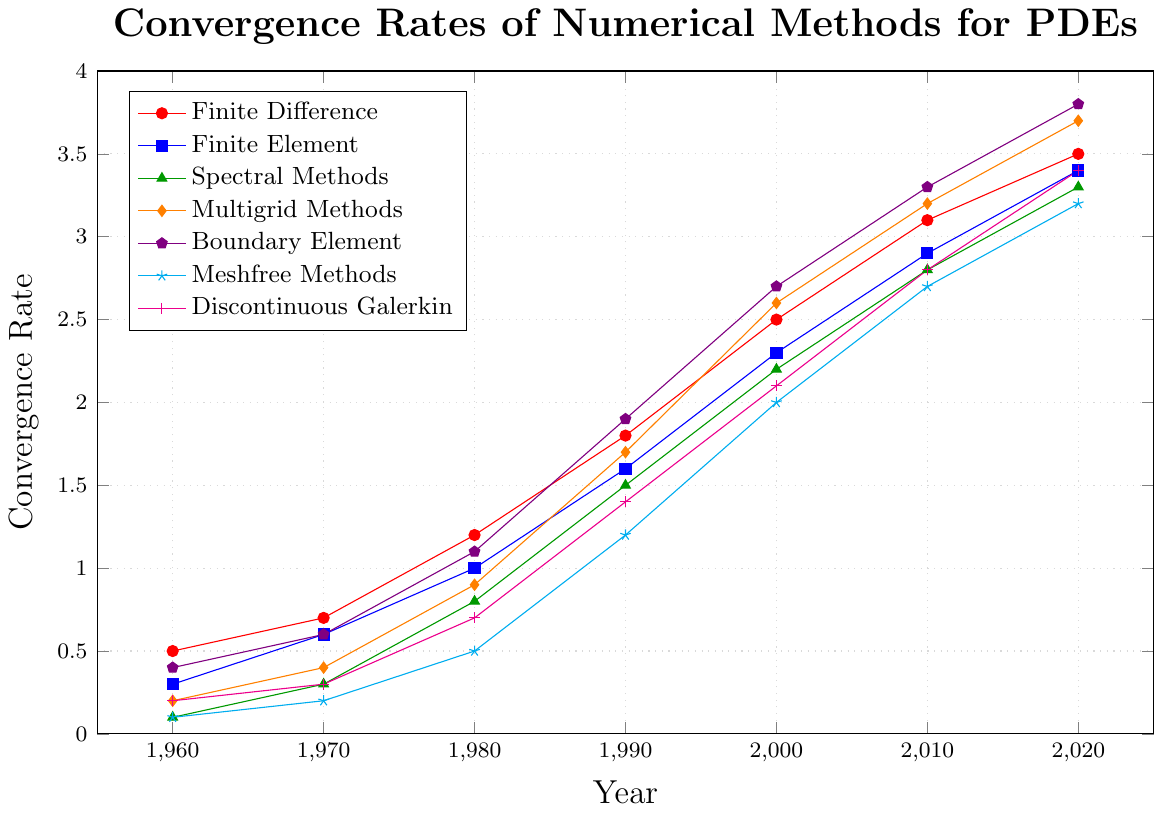What method has the highest convergence rate in 2020? By looking at the 2020 data point, Boundary Element has the highest value: 3.8.
Answer: Boundary Element How did the convergence rate of Finite Difference change from 1960 to 2020? The convergence rate of Finite Difference in 1960 is 0.5 and in 2020 is 3.5. The change is calculated as 3.5 - 0.5 = 3.0.
Answer: 3.0 Which method showed the most significant increase in convergence rate between 1980 and 2000? To find this, we calculate the increase for each method between 1980 and 2000: Finite Difference (2.5-1.2=1.3), Finite Element (2.3-1.0=1.3), Spectral Methods (2.2-0.8=1.4), Multigrid Methods (2.6-0.9=1.7), Boundary Element (2.7-1.1=1.6), Meshfree Methods (2.0-0.5=1.5), Discontinuous Galerkin (2.1-0.7=1.4). Thus, Multigrid Methods showed the most significant increase: 1.7.
Answer: Multigrid Methods Compare the convergence rates of Finite Difference and Discontinuous Galerkin in 2010. Which is higher? In 2010, the convergence rate of Finite Difference is 3.1, and Discontinuous Galerkin is 2.8. Finite Difference is higher.
Answer: Finite Difference From the plotted data, which numerical method consistently showed the lowest convergence rate from 1960 to 2020? Scanning the data, Spectral Methods start with the lowest value in 1960 and remain relatively lowest or among the lowest compared to other methods throughout the years.
Answer: Spectral Methods Calculate the average convergence rate of Boundary Element methods from 1960 to 2020. To find the average, sum up the values from 1960 to 2020 and divide by the number of data points: (0.4 + 0.6 + 1.1 + 1.9 + 2.7 + 3.3 + 3.8)/7 = 1.97.
Answer: 1.97 In which decade did the Multigrid Methods experience the steepest increase in convergence rate? To determine the steepest increase, we look at differences per decade: 1960-1970 (0.4-0.2=0.2), 1970-1980 (0.9-0.4=0.5), 1980-1990 (1.7-0.9=0.8), 1990-2000 (2.6-1.7=0.9), 2000-2010 (3.2-2.6=0.6), 2010-2020 (3.7-3.2=0.5). The steepest increase occurred from 1990-2000 at 0.9.
Answer: 1990-2000 Which method crosses a convergence rate of 1 first according to the plot? Observing the data points, Finite Difference crosses a convergence rate of 1 in 1980.
Answer: Finite Difference What is the difference in the convergence rates between Boundary Element and Meshfree Methods in 2020? For 2020, Boundary Element has a rate of 3.8 and Meshfree Methods have a rate of 3.2. The difference is 3.8 - 3.2 = 0.6.
Answer: 0.6 How many numerical methods have convergence rates greater than 3 in 2010? Checking the 2010 data, the methods with rates greater than 3 are Finite Difference (3.1), Multigrid Methods (3.2), Boundary Element (3.3), and Discontinuous Galerkin (3.4). Thus, there are 4 methods.
Answer: 4 